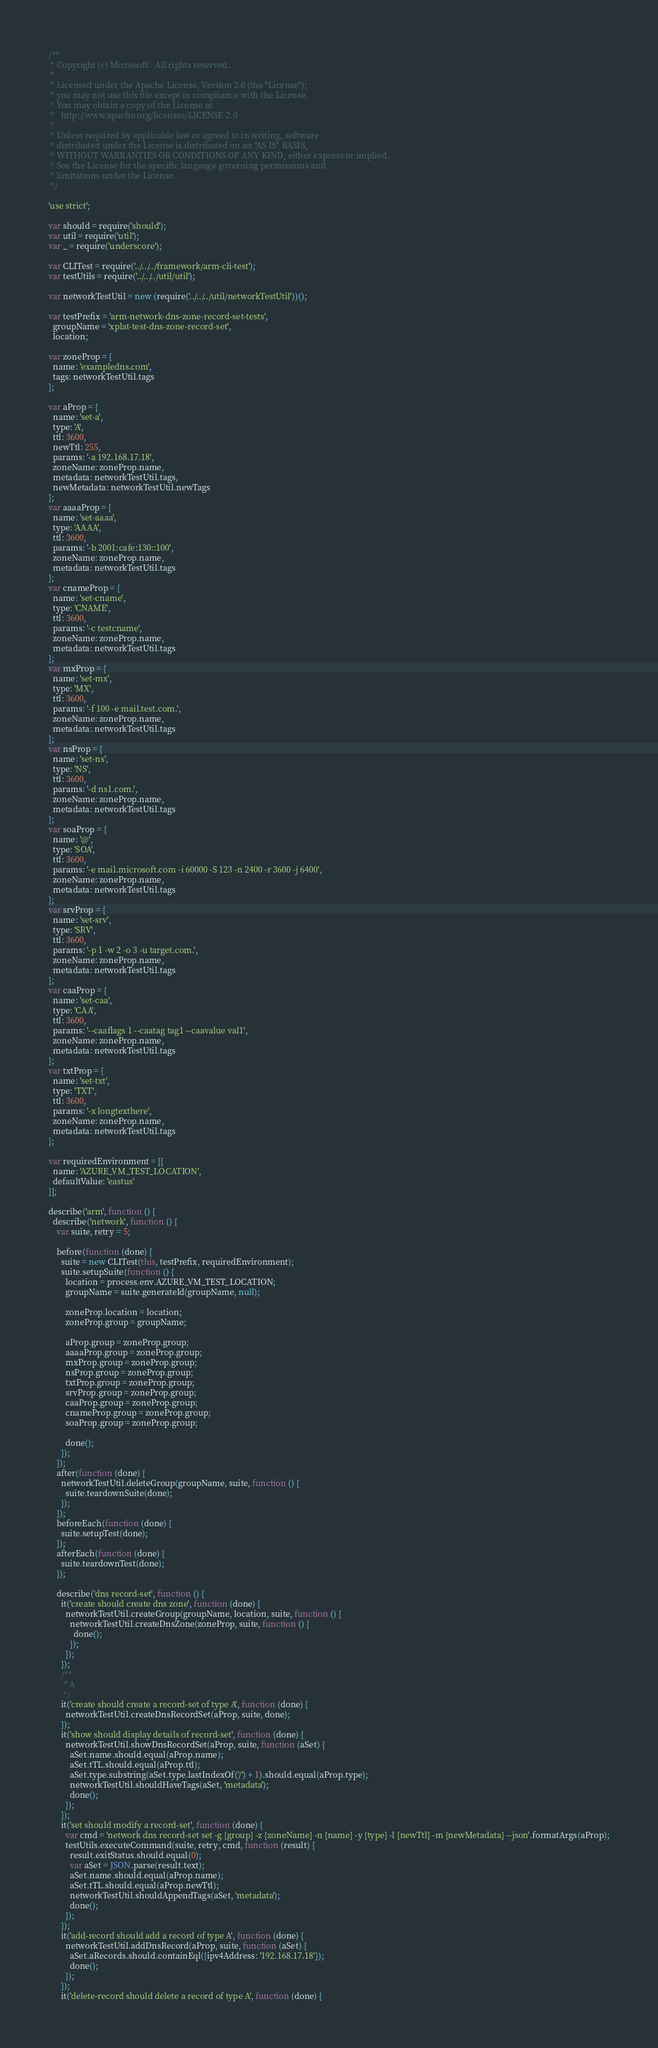Convert code to text. <code><loc_0><loc_0><loc_500><loc_500><_JavaScript_>/**
 * Copyright (c) Microsoft.  All rights reserved.
 *
 * Licensed under the Apache License, Version 2.0 (the "License");
 * you may not use this file except in compliance with the License.
 * You may obtain a copy of the License at
 *   http://www.apache.org/licenses/LICENSE-2.0
 *
 * Unless required by applicable law or agreed to in writing, software
 * distributed under the License is distributed on an "AS IS" BASIS,
 * WITHOUT WARRANTIES OR CONDITIONS OF ANY KIND, either express or implied.
 * See the License for the specific language governing permissions and
 * limitations under the License.
 */

'use strict';

var should = require('should');
var util = require('util');
var _ = require('underscore');

var CLITest = require('../../../framework/arm-cli-test');
var testUtils = require('../../../util/util');

var networkTestUtil = new (require('../../../util/networkTestUtil'))();

var testPrefix = 'arm-network-dns-zone-record-set-tests',
  groupName = 'xplat-test-dns-zone-record-set',
  location;

var zoneProp = {
  name: 'exampledns.com',
  tags: networkTestUtil.tags
};

var aProp = {
  name: 'set-a',
  type: 'A',
  ttl: 3600,
  newTtl: 255,
  params: '-a 192.168.17.18',
  zoneName: zoneProp.name,
  metadata: networkTestUtil.tags,
  newMetadata: networkTestUtil.newTags
};
var aaaaProp = {
  name: 'set-aaaa',
  type: 'AAAA',
  ttl: 3600,
  params: '-b 2001:cafe:130::100',
  zoneName: zoneProp.name,
  metadata: networkTestUtil.tags
};
var cnameProp = {
  name: 'set-cname',
  type: 'CNAME',
  ttl: 3600,
  params: '-c testcname',
  zoneName: zoneProp.name,
  metadata: networkTestUtil.tags
};
var mxProp = {
  name: 'set-mx',
  type: 'MX',
  ttl: 3600,
  params: '-f 100 -e mail.test.com.',
  zoneName: zoneProp.name,
  metadata: networkTestUtil.tags
};
var nsProp = {
  name: 'set-ns',
  type: 'NS',
  ttl: 3600,
  params: '-d ns1.com.',
  zoneName: zoneProp.name,
  metadata: networkTestUtil.tags
};
var soaProp = {
  name: '@',
  type: 'SOA',
  ttl: 3600,
  params: '-e mail.microsoft.com -i 60000 -S 123 -n 2400 -r 3600 -j 6400',
  zoneName: zoneProp.name,
  metadata: networkTestUtil.tags
};
var srvProp = {
  name: 'set-srv',
  type: 'SRV',
  ttl: 3600,
  params: '-p 1 -w 2 -o 3 -u target.com.',
  zoneName: zoneProp.name,
  metadata: networkTestUtil.tags
};
var caaProp = {
  name: 'set-caa',
  type: 'CAA',
  ttl: 3600,
  params: '--caaflags 1 --caatag tag1 --caavalue val1',
  zoneName: zoneProp.name,
  metadata: networkTestUtil.tags
};
var txtProp = {
  name: 'set-txt',
  type: 'TXT',
  ttl: 3600,
  params: '-x longtexthere',
  zoneName: zoneProp.name,
  metadata: networkTestUtil.tags
};

var requiredEnvironment = [{
  name: 'AZURE_VM_TEST_LOCATION',
  defaultValue: 'eastus'
}];

describe('arm', function () {
  describe('network', function () {
    var suite, retry = 5;

    before(function (done) {
      suite = new CLITest(this, testPrefix, requiredEnvironment);
      suite.setupSuite(function () {
        location = process.env.AZURE_VM_TEST_LOCATION;
        groupName = suite.generateId(groupName, null);

        zoneProp.location = location;
        zoneProp.group = groupName;

        aProp.group = zoneProp.group;
        aaaaProp.group = zoneProp.group;
        mxProp.group = zoneProp.group;
        nsProp.group = zoneProp.group;
        txtProp.group = zoneProp.group;
        srvProp.group = zoneProp.group;
        caaProp.group = zoneProp.group;
        cnameProp.group = zoneProp.group;
        soaProp.group = zoneProp.group;

        done();
      });
    });
    after(function (done) {
      networkTestUtil.deleteGroup(groupName, suite, function () {
        suite.teardownSuite(done);
      });
    });
    beforeEach(function (done) {
      suite.setupTest(done);
    });
    afterEach(function (done) {
      suite.teardownTest(done);
    });

    describe('dns record-set', function () {
      it('create should create dns zone', function (done) {
        networkTestUtil.createGroup(groupName, location, suite, function () {
          networkTestUtil.createDnsZone(zoneProp, suite, function () {
            done();
          });
        });
      });
      /**
       * A
       */
      it('create should create a record-set of type A', function (done) {
        networkTestUtil.createDnsRecordSet(aProp, suite, done);
      });
      it('show should display details of record-set', function (done) {
        networkTestUtil.showDnsRecordSet(aProp, suite, function (aSet) {
          aSet.name.should.equal(aProp.name);
          aSet.tTL.should.equal(aProp.ttl);
          aSet.type.substring(aSet.type.lastIndexOf('/') + 1).should.equal(aProp.type);
          networkTestUtil.shouldHaveTags(aSet, 'metadata');
          done();
        });
      });
      it('set should modify a record-set', function (done) {
        var cmd = 'network dns record-set set -g {group} -z {zoneName} -n {name} -y {type} -l {newTtl} -m {newMetadata} --json'.formatArgs(aProp);
        testUtils.executeCommand(suite, retry, cmd, function (result) {
          result.exitStatus.should.equal(0);
          var aSet = JSON.parse(result.text);
          aSet.name.should.equal(aProp.name);
          aSet.tTL.should.equal(aProp.newTtl);
          networkTestUtil.shouldAppendTags(aSet, 'metadata');
          done();
        });
      });
      it('add-record should add a record of type A', function (done) {
        networkTestUtil.addDnsRecord(aProp, suite, function (aSet) {
          aSet.aRecords.should.containEql({ipv4Address: '192.168.17.18'});
          done();
        });
      });
      it('delete-record should delete a record of type A', function (done) {</code> 